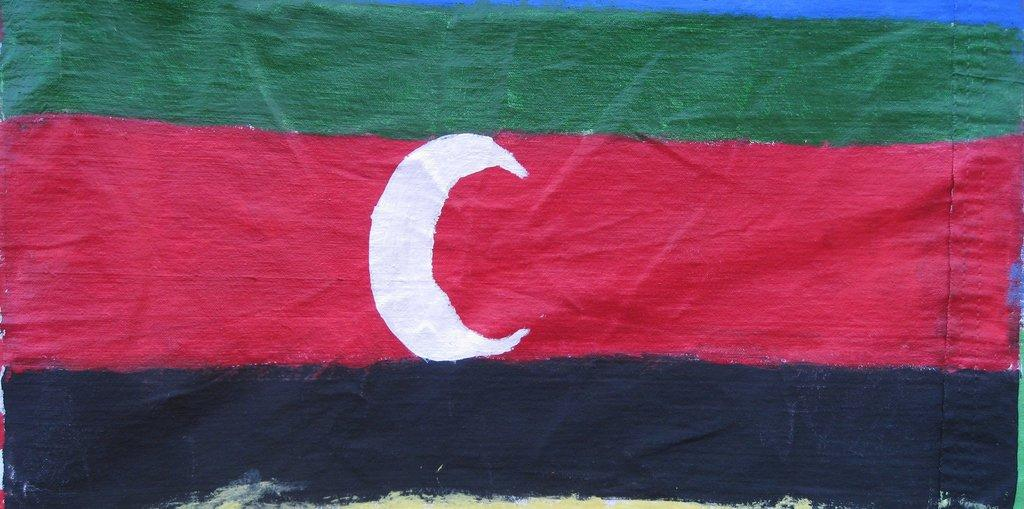What flag can be seen in the image? The Darfur flag is present in the image. How many cows are grazing on the trail in the image? There are no cows or trails present in the image; it only features the Darfur flag. 